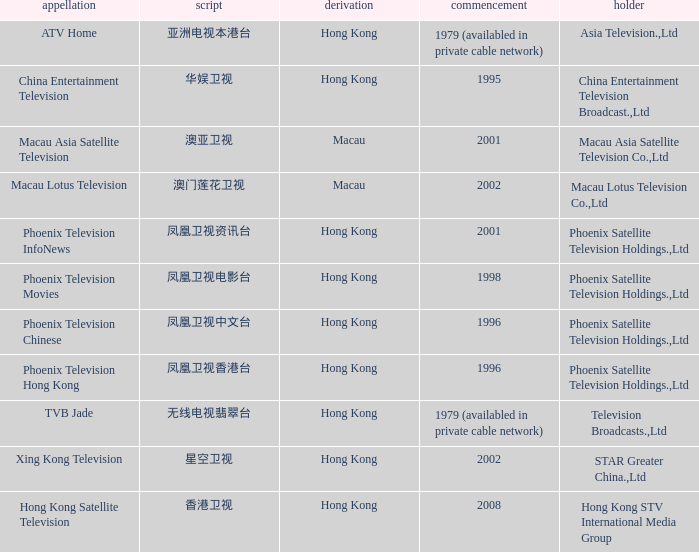Which company launched in 1996 and has a Hanzi of 凤凰卫视中文台? Phoenix Television Chinese. Write the full table. {'header': ['appellation', 'script', 'derivation', 'commencement', 'holder'], 'rows': [['ATV Home', '亚洲电视本港台', 'Hong Kong', '1979 (availabled in private cable network)', 'Asia Television.,Ltd'], ['China Entertainment Television', '华娱卫视', 'Hong Kong', '1995', 'China Entertainment Television Broadcast.,Ltd'], ['Macau Asia Satellite Television', '澳亚卫视', 'Macau', '2001', 'Macau Asia Satellite Television Co.,Ltd'], ['Macau Lotus Television', '澳门莲花卫视', 'Macau', '2002', 'Macau Lotus Television Co.,Ltd'], ['Phoenix Television InfoNews', '凤凰卫视资讯台', 'Hong Kong', '2001', 'Phoenix Satellite Television Holdings.,Ltd'], ['Phoenix Television Movies', '凤凰卫视电影台', 'Hong Kong', '1998', 'Phoenix Satellite Television Holdings.,Ltd'], ['Phoenix Television Chinese', '凤凰卫视中文台', 'Hong Kong', '1996', 'Phoenix Satellite Television Holdings.,Ltd'], ['Phoenix Television Hong Kong', '凤凰卫视香港台', 'Hong Kong', '1996', 'Phoenix Satellite Television Holdings.,Ltd'], ['TVB Jade', '无线电视翡翠台', 'Hong Kong', '1979 (availabled in private cable network)', 'Television Broadcasts.,Ltd'], ['Xing Kong Television', '星空卫视', 'Hong Kong', '2002', 'STAR Greater China.,Ltd'], ['Hong Kong Satellite Television', '香港卫视', 'Hong Kong', '2008', 'Hong Kong STV International Media Group']]} 